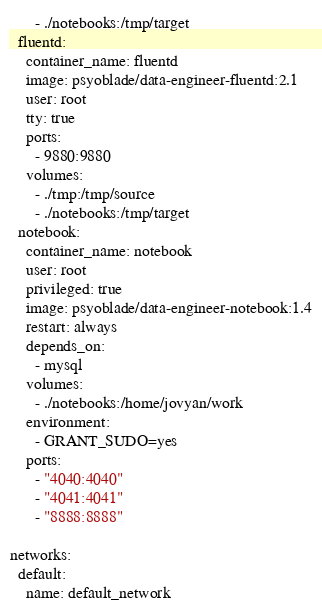<code> <loc_0><loc_0><loc_500><loc_500><_YAML_>      - ./notebooks:/tmp/target
  fluentd:
    container_name: fluentd
    image: psyoblade/data-engineer-fluentd:2.1
    user: root
    tty: true
    ports:
      - 9880:9880
    volumes:
      - ./tmp:/tmp/source
      - ./notebooks:/tmp/target
  notebook:
    container_name: notebook
    user: root
    privileged: true
    image: psyoblade/data-engineer-notebook:1.4
    restart: always
    depends_on:
      - mysql
    volumes:
      - ./notebooks:/home/jovyan/work
    environment:
      - GRANT_SUDO=yes
    ports:
      - "4040:4040"
      - "4041:4041"
      - "8888:8888"

networks:
  default:
    name: default_network
</code> 